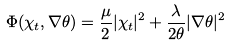<formula> <loc_0><loc_0><loc_500><loc_500>\Phi ( \chi _ { t } , \nabla \theta ) = \frac { \mu } { 2 } | \chi _ { t } | ^ { 2 } + \frac { \lambda } { 2 \theta } | \nabla \theta | ^ { 2 }</formula> 